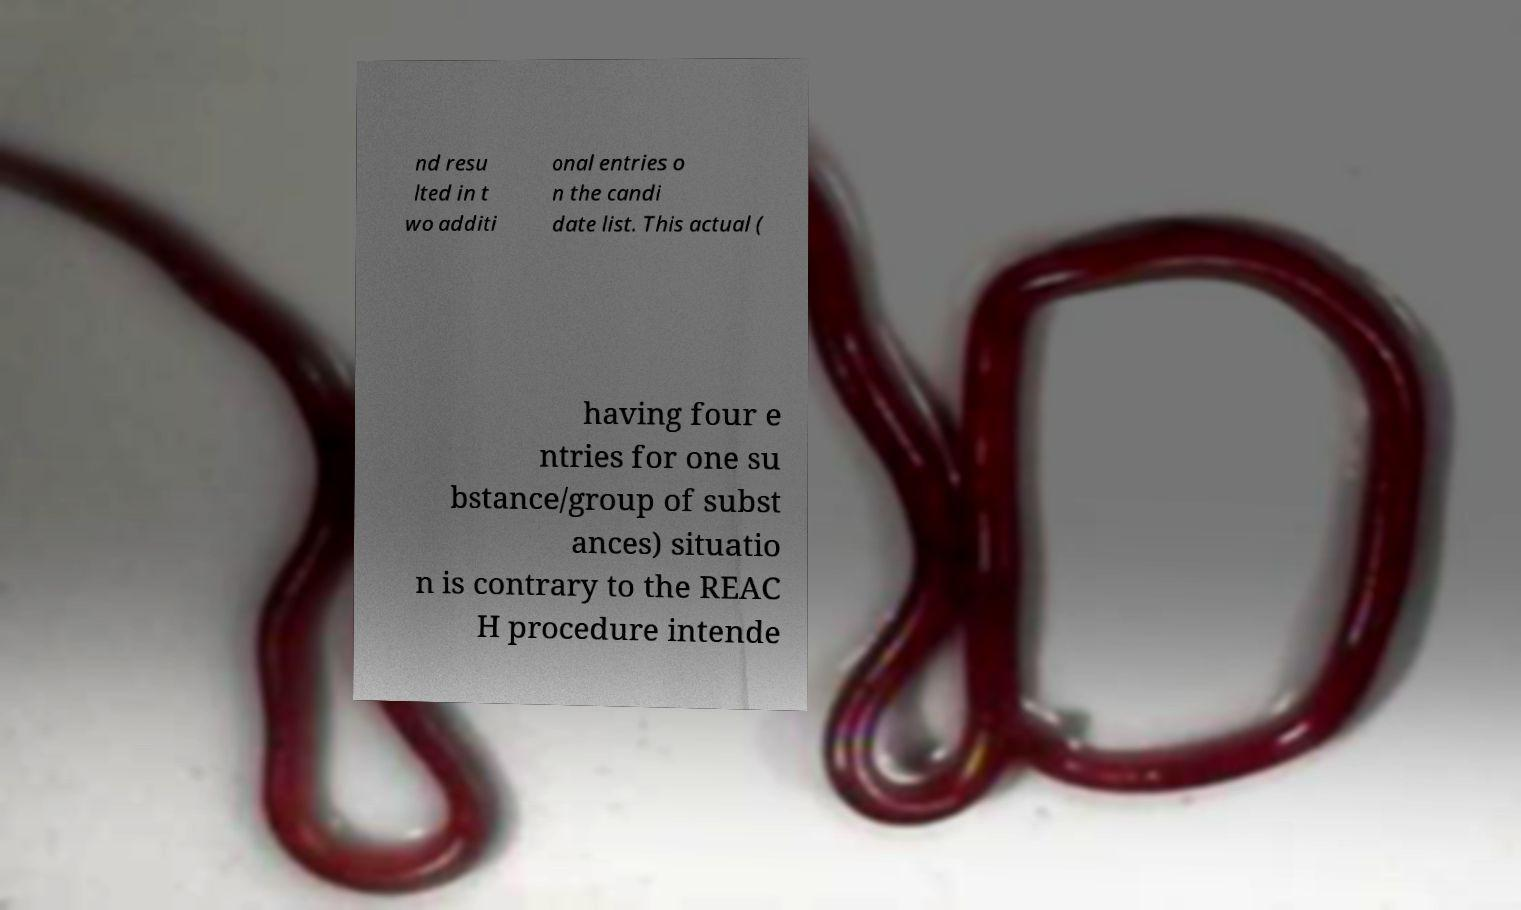Can you read and provide the text displayed in the image?This photo seems to have some interesting text. Can you extract and type it out for me? nd resu lted in t wo additi onal entries o n the candi date list. This actual ( having four e ntries for one su bstance/group of subst ances) situatio n is contrary to the REAC H procedure intende 